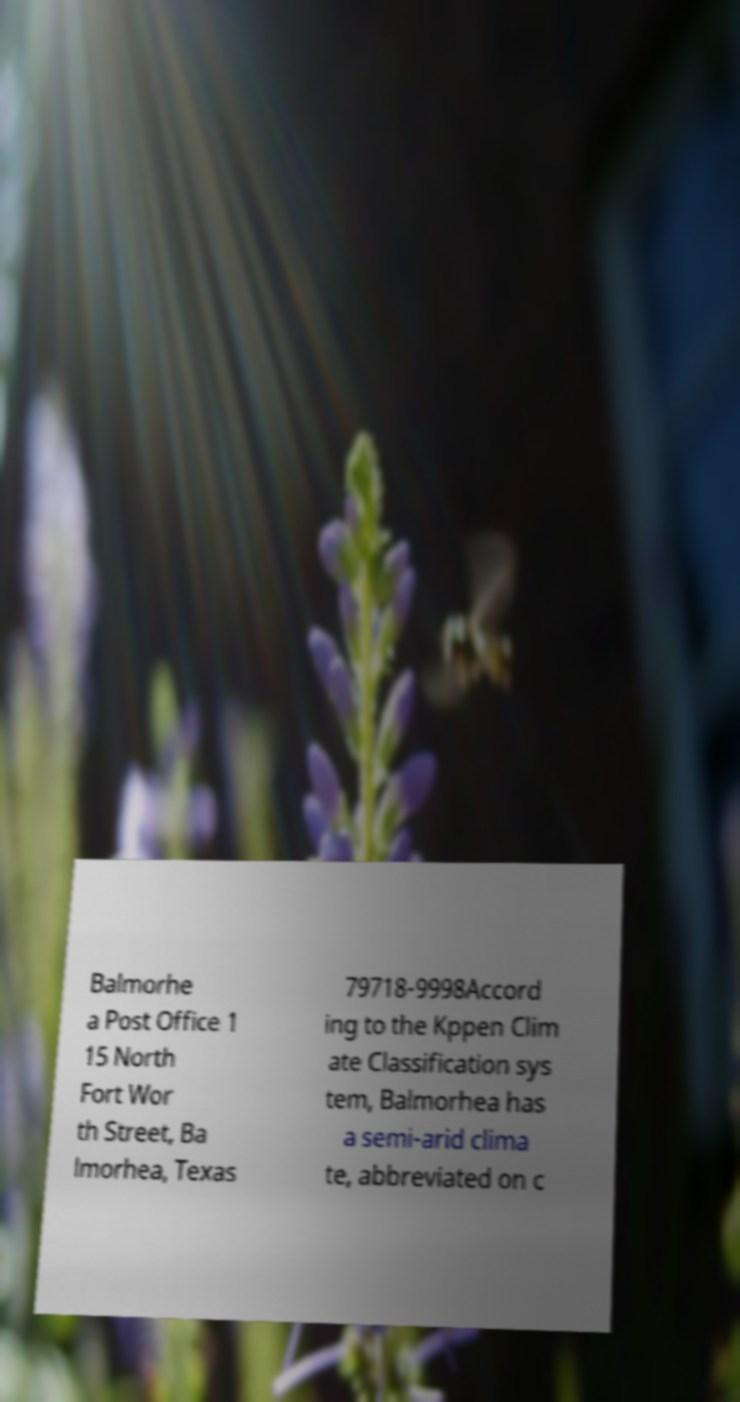What messages or text are displayed in this image? I need them in a readable, typed format. Balmorhe a Post Office 1 15 North Fort Wor th Street, Ba lmorhea, Texas 79718-9998Accord ing to the Kppen Clim ate Classification sys tem, Balmorhea has a semi-arid clima te, abbreviated on c 